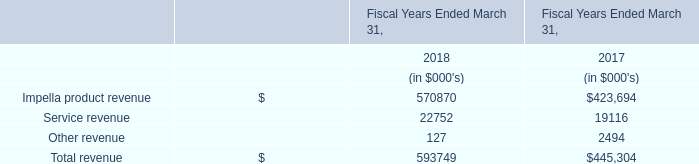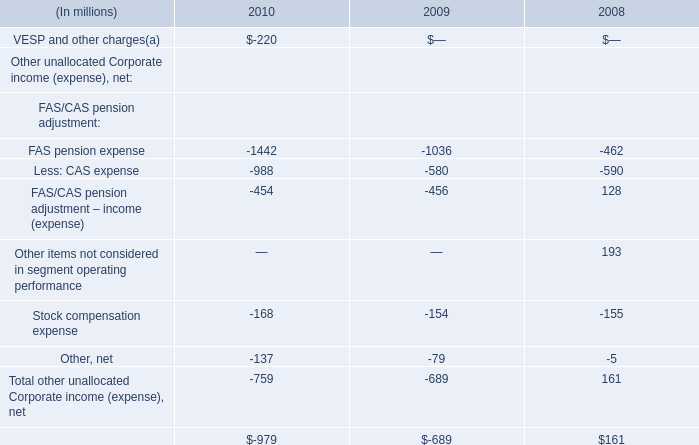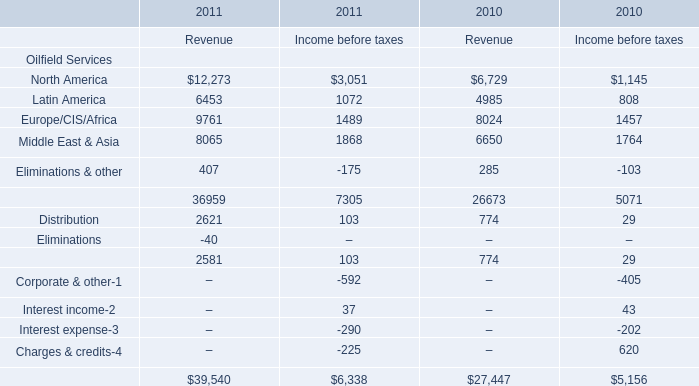What is the average value of Latin America for Oilfield Services for Revenue and Less: CAS expense in 2010? (in million) 
Computations: ((4985 - 988) / 2)
Answer: 1998.5. 